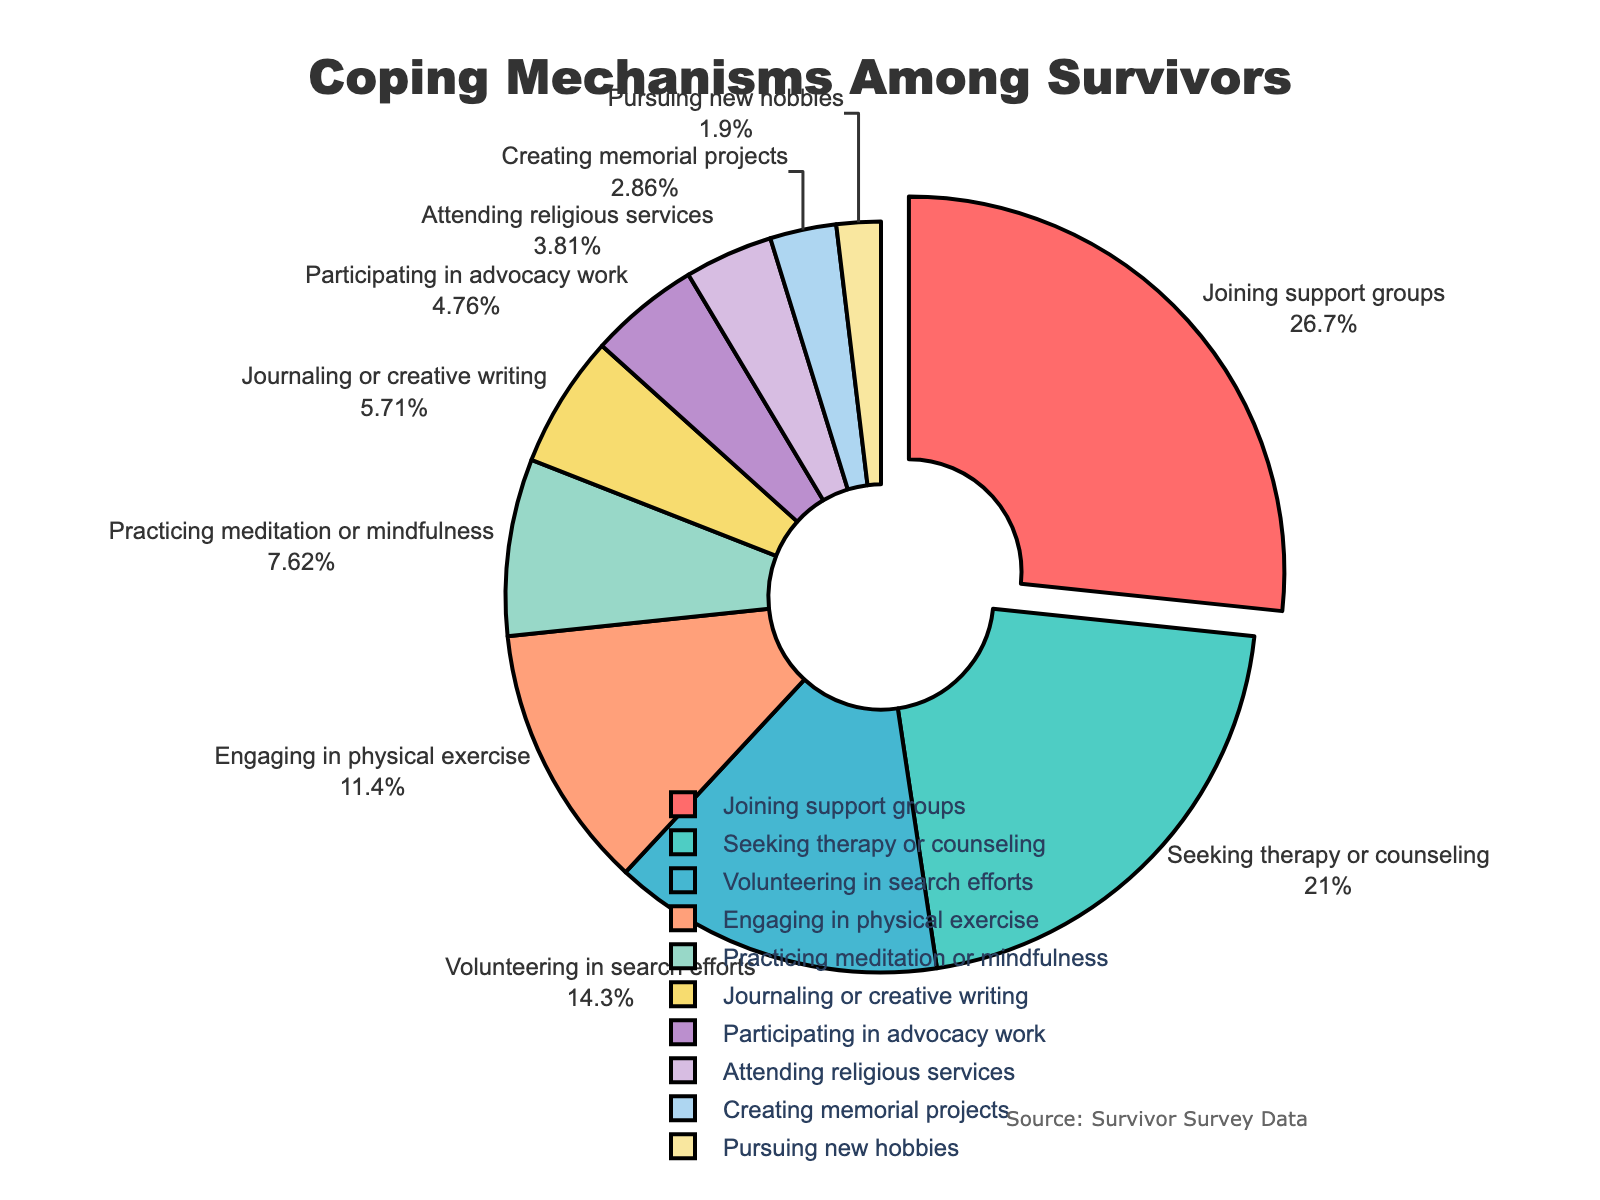What is the most common coping mechanism among survivors? The chart shows various coping mechanisms and their percentage representations. The largest segment represents Joining support groups, which is the most common coping mechanism at 28%.
Answer: Joining support groups Which coping mechanism has the second highest percentage? The visualization indicates different coping mechanisms by percentage. The second largest segment of the pie chart is Seeking therapy or counseling with 22%.
Answer: Seeking therapy or counseling How much higher is the percentage of survivors joining support groups compared to those pursuing new hobbies? The pie chart displays the percentages of various coping mechanisms. Joining support groups is 28%, and pursuing new hobbies is 2%. So, the difference is \(28\% - 2\% = 26\%\).
Answer: 26% What is the combined percentage of survivors who engage in physical exercise and practicing meditation or mindfulness? From the pie chart, physical exercise constitutes 12% and meditation/mindfulness constitutes 8%. The combined percentage is \(12\% + 8\% = 20\%\).
Answer: 20% Among the coping mechanisms, which one is represented by the smallest segment and what is its percentage? The visualization shows various coping mechanisms with their respective sizes. The smallest segment represents pursuing new hobbies at 2%.
Answer: Pursuing new hobbies at 2% Compare the percentage of survivors participating in advocacy work to those attending religious services. Which is higher and by how much? The pie chart shows advocacy work at 5% and religious services at 4%. Advocacy work is higher by \(5\% - 4\% = 1\%\).
Answer: Advocacy work by 1% How much more prevalent is journaling or creative writing compared to creating memorial projects? From the pie chart, journaling or creative writing is at 6% and creating memorial projects is at 3%. The difference is \(6\% - 3\% = 3\%\).
Answer: 3% What is the total percentage of survivors who engage in activities other than the top three coping mechanisms? The top three mechanisms are Joining support groups (28%), Seeking therapy or counseling (22%), and Volunteering in search efforts (15%). The total percentage of these is \(28\% + 22\% + 15\% = 65\%\). Thus, those engaging in other activities is \(100\% - 65\% = 35\%\).
Answer: 35% Which coping mechanism is represented by the red color, and what is its percentage? Looking at the description of the color associated segments, the red color represents Joining support groups. The percentage is 28%.
Answer: Joining support groups at 28% How does the percentage of survivors attending religious services compare to those creating memorial projects? The pie chart indicates religious services at 4% and memorial projects at 3%. Religious services are higher by \(4\% - 3\% = 1\%\).
Answer: Religious services by 1% 